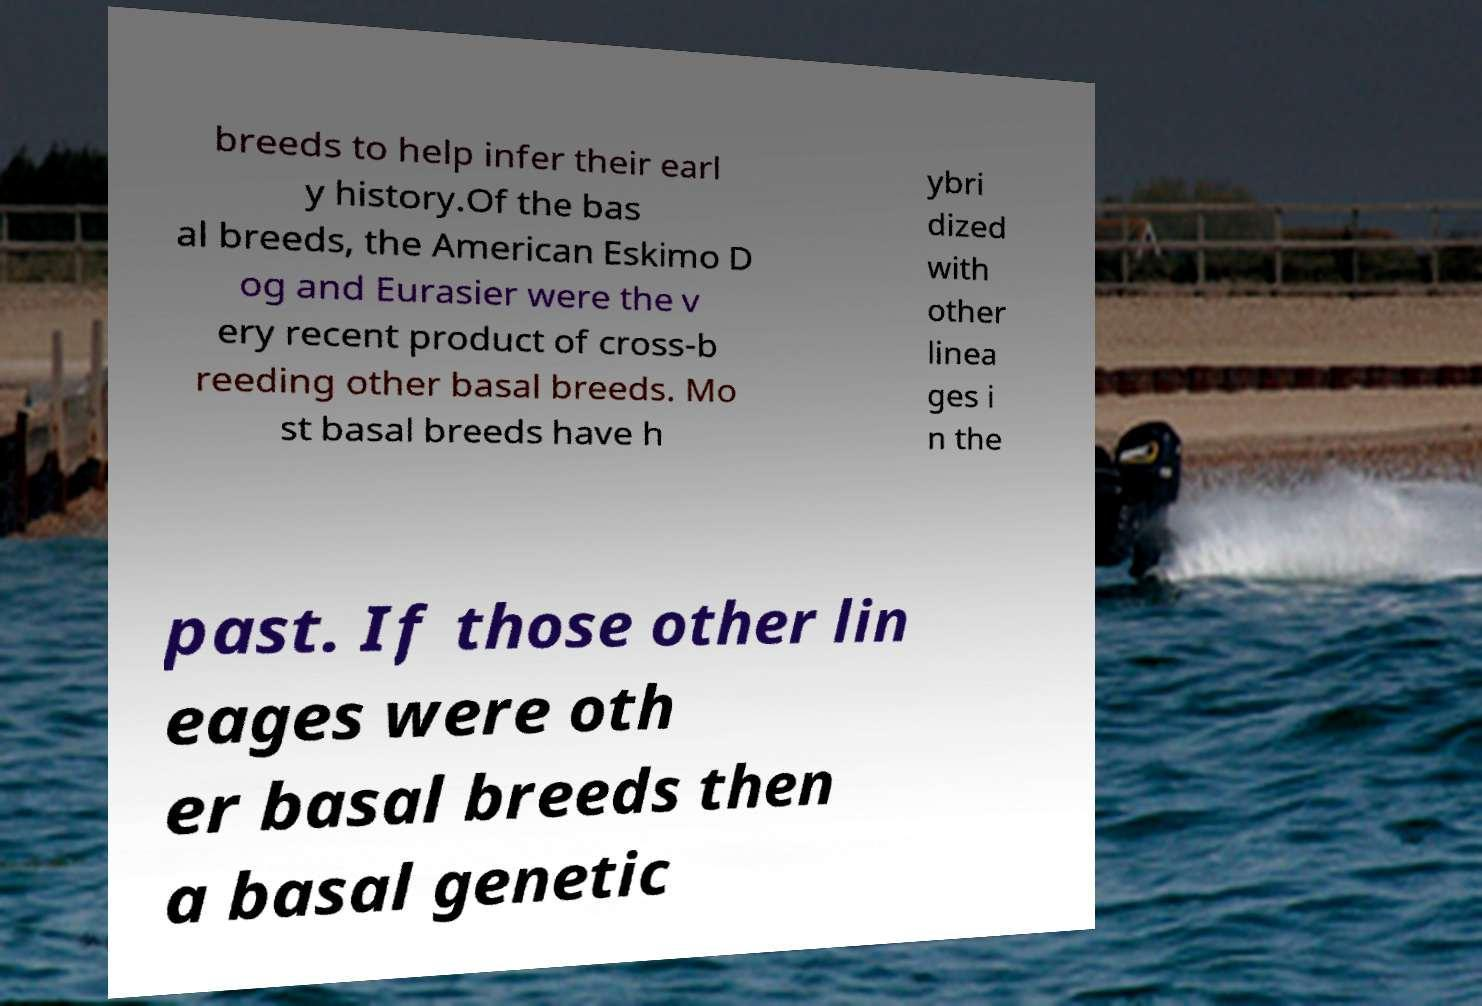Could you assist in decoding the text presented in this image and type it out clearly? breeds to help infer their earl y history.Of the bas al breeds, the American Eskimo D og and Eurasier were the v ery recent product of cross-b reeding other basal breeds. Mo st basal breeds have h ybri dized with other linea ges i n the past. If those other lin eages were oth er basal breeds then a basal genetic 